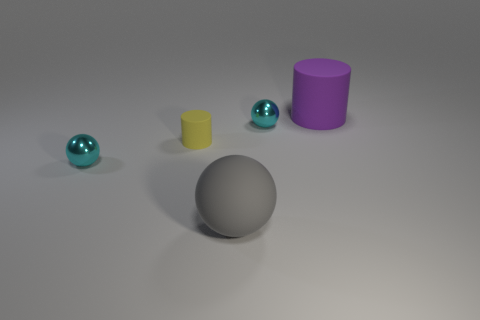The yellow cylinder has what size?
Ensure brevity in your answer.  Small. Do the matte ball and the small rubber cylinder have the same color?
Offer a very short reply. No. How many objects are large green rubber balls or objects that are in front of the purple thing?
Offer a terse response. 4. What number of yellow rubber things are behind the shiny object behind the cylinder that is to the left of the big purple matte cylinder?
Keep it short and to the point. 0. What number of large purple rubber objects are there?
Make the answer very short. 1. Is the size of the cylinder left of the purple rubber cylinder the same as the large purple cylinder?
Provide a succinct answer. No. How many metal objects are either cyan balls or big gray things?
Offer a very short reply. 2. How many purple matte objects are left of the large matte object to the left of the purple matte object?
Give a very brief answer. 0. What shape is the matte object that is on the right side of the small yellow object and behind the large gray sphere?
Provide a succinct answer. Cylinder. The sphere to the left of the big matte thing that is in front of the small shiny sphere in front of the yellow cylinder is made of what material?
Your answer should be compact. Metal. 